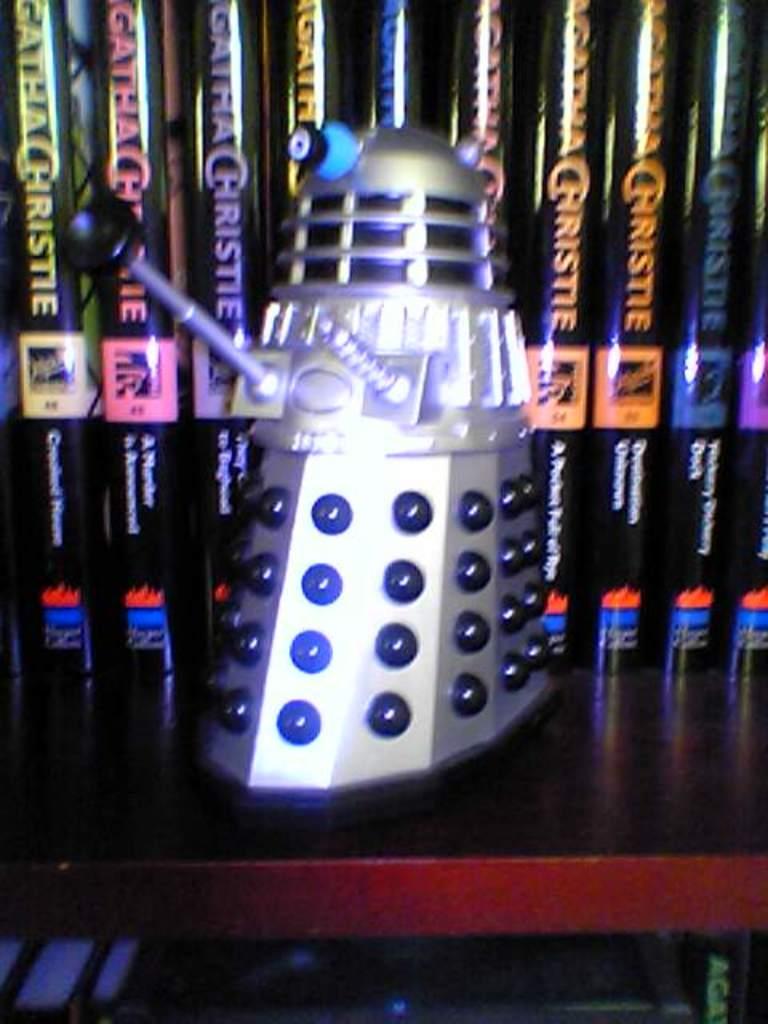What series of books are behind r2d2?
Your answer should be compact. Agatha christie. 